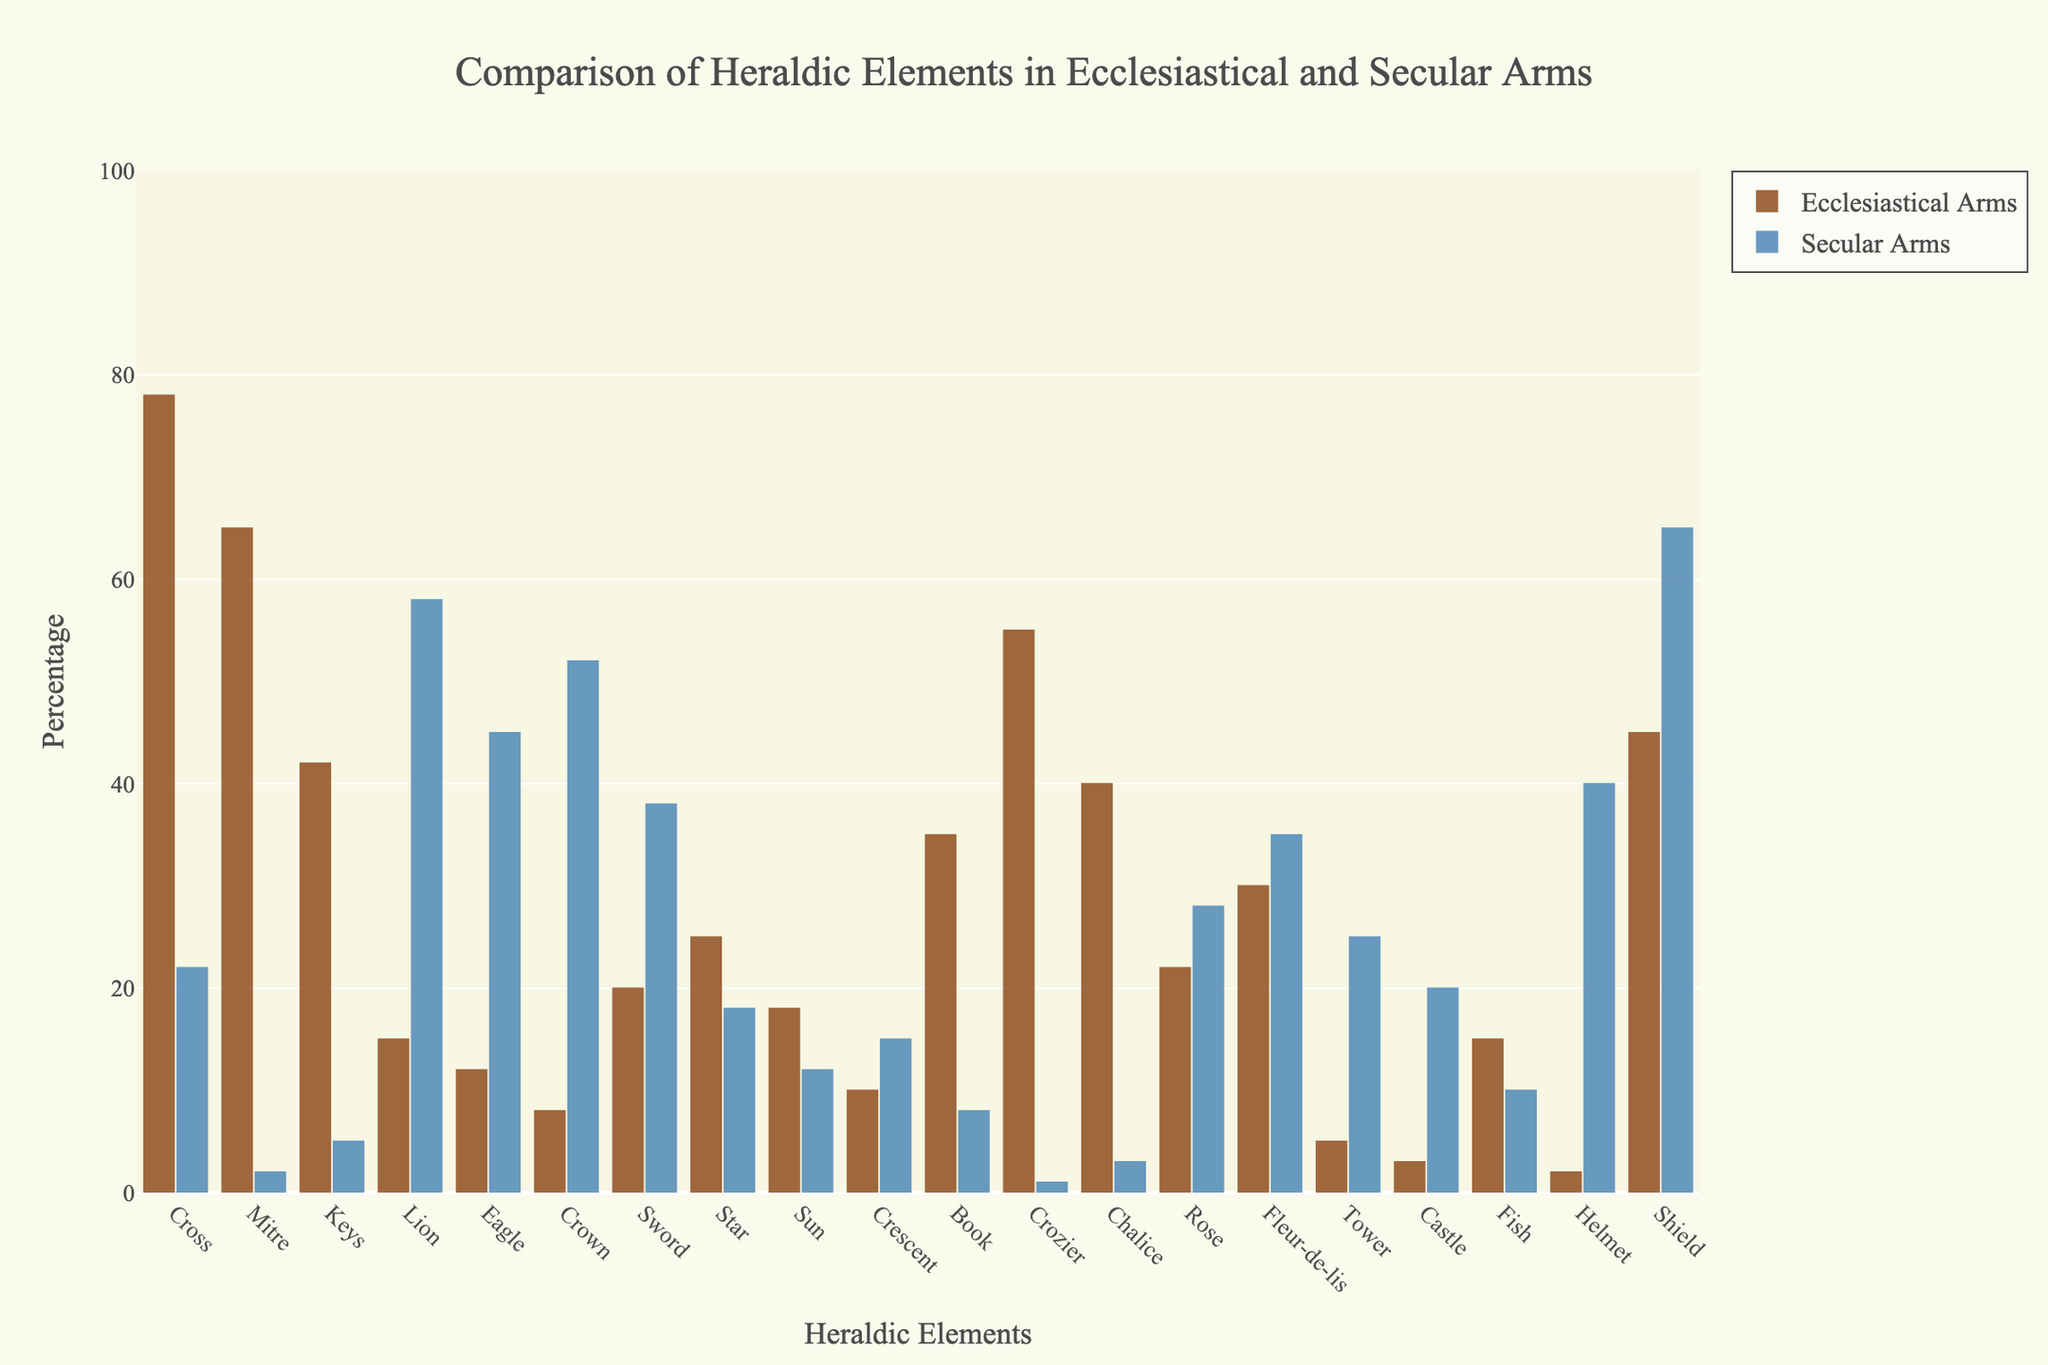What's the most common heraldic element in ecclesiastical arms, and how does its percentage compare to its presence in secular arms? The element 'Cross' is the most common in ecclesiastical arms at 78%. In secular arms, it is present at 22%. Cross: 78% (Ecclesiastical) vs. 22% (Secular)
Answer: Cross; 78% vs. 22% Which heraldic elements are exclusively associated with ecclesiastical arms, appearing at significantly higher percentages than in secular arms? 'Mitre' (65% vs. 2%), 'Keys' (42% vs. 5%), 'Crozier' (55% vs. 1%), and 'Chalice' (40% vs. 3%) each have a significantly higher percentage in ecclesiastical arms compared to secular arms, indicating exclusivity.
Answer: Mitre, Keys, Crozier, Chalice Which heraldic elements are more prevalent in secular arms than in ecclesiastical arms, based on the bar chart heights? 'Lion' (58% vs. 15%), 'Eagle' (45% vs. 12%), 'Crown' (52% vs. 8%), 'Helmet' (40% vs. 2%), and 'Shield' (65% vs. 45%) are more prevalent in secular arms than in ecclesiastical arms.
Answer: Lion, Eagle, Crown, Helmet, Shield What are the percentages for 'Sword' in both ecclesiastical and secular arms? Which arm type has a higher percentage? 'Sword' appears in 20% of ecclesiastical arms and 38% of secular arms. Secular arms have a higher percentage.
Answer: Ecclesiastical: 20%, Secular: 38% Calculate the total percentage of the elements only found in ecclesiastical arms and not in secular arms. What's their combined percentage? Elements exclusive to ecclesiastical arms are identified: Mitre (65%), Keys (42%), Crozier (55%), Chalice (40%). Combined percentage: 65 + 42 + 55 + 40 = 202%.
Answer: 202% Compare the elements with an equal or very similar percentage presence in both arms types, based on visual inspection of bar heights. 'Fleur-de-lis' (30% in ecclesiastical and 35% in secular), and 'Rose' (22% in ecclesiastical and 28% in secular) show close percentages in both arm types.
Answer: Fleur-de-lis, Rose Which heraldic elements have less than 10% presence in both ecclesiastical and secular arms? 'Helmet' appears with 2% in ecclesiastical arms and 'Castle' with 3%. 'Crescent' appears with 10% in ecclesiastical arms and 15% in secular arms.
Answer: Castle Sum the percentages of elements where secular arms have a higher percentage than ecclesiastical arms and compare it to the total percentage for ecclesiastical arms. Summing elements where secular arms percentages are higher: Lion (58%), Eagle (45%), Crown (52%), Helmet (40%), Shield (65%): 58+45+52+40+65 = 260%. Comparing to combined ecclesiastical elements: Not specified; each element total is unique.
Answer: 260% Which elements are associated with religious symbolism and have higher percentages in ecclesiastical arms? Elements with higher ecclesiastical percentages: Cross, Mitre, Keys, Crozier, Chalice, Book, Star are linked to religious symbols and rituals.
Answer: Cross, Mitre, Keys, Crozier, Chalice, Book, Star 